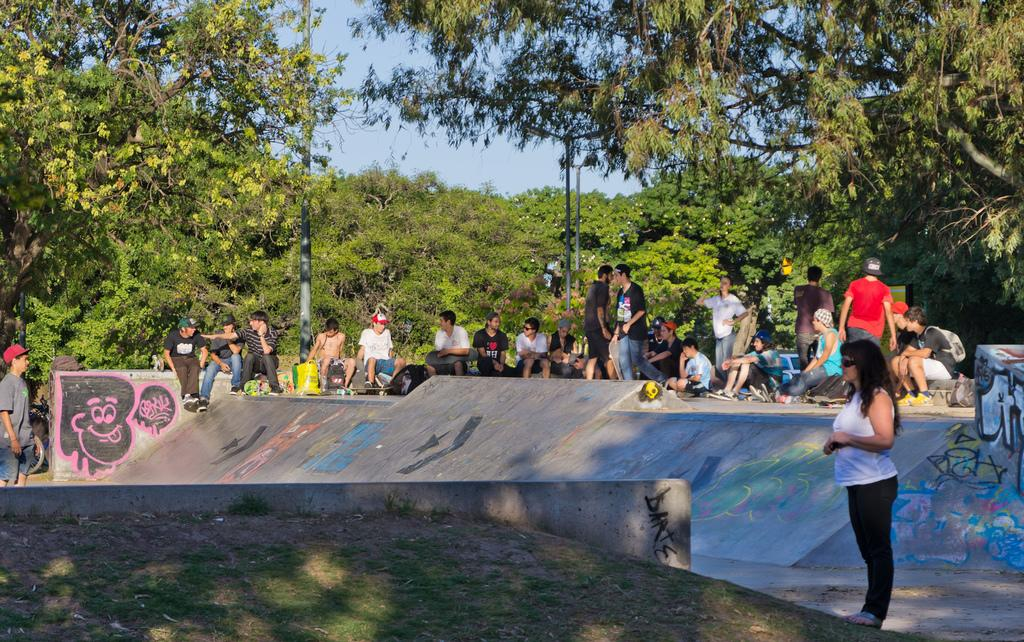What are the people in the image doing? The people in the image are sitting on the ground. What can be seen in the background of the image? There are trees visible in the background of the image. What type of bone can be seen in the hands of the people in the image? There is no bone present in the image; the people are sitting on the ground without any visible bones. 